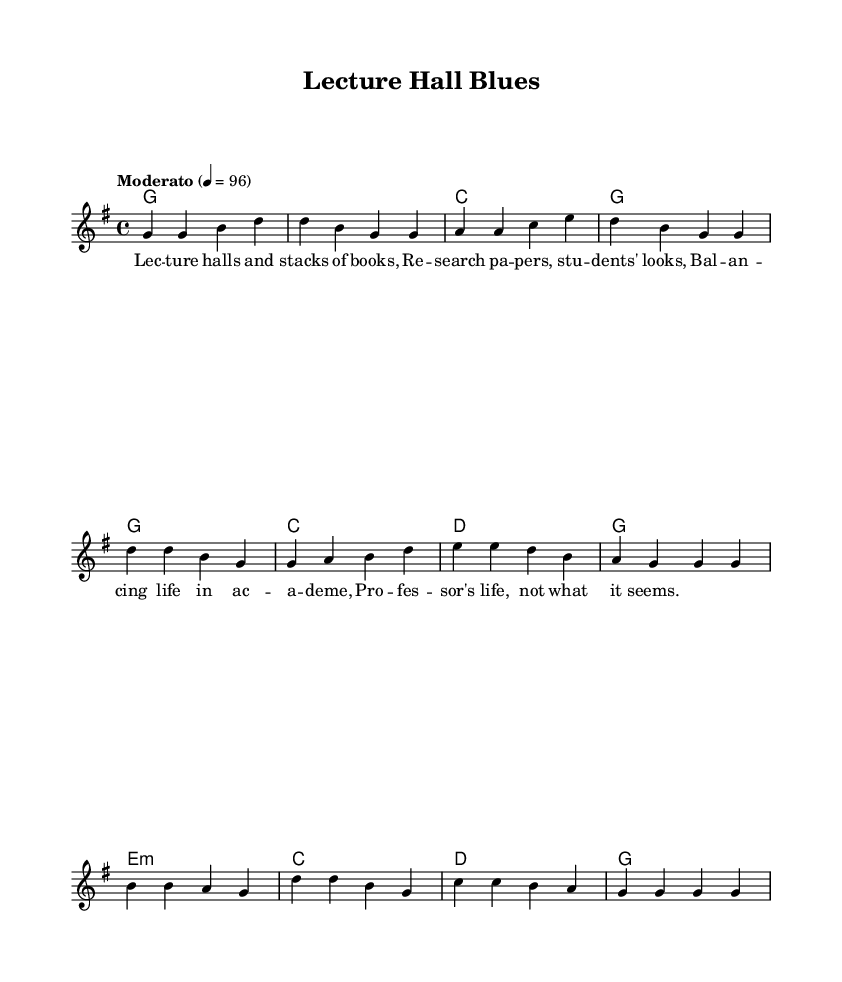What is the key signature of this music? The key signature is indicated by the presence of one sharp, which correlates with G major.
Answer: G major What is the time signature of the piece? The time signature is shown at the beginning of the score as 4/4, indicating that there are four beats per measure.
Answer: 4/4 What is the tempo marking of this piece? The tempo marking at the beginning states "Moderato" and provides a specific metronome marking of 96 beats per minute.
Answer: Moderato What are the first four notes of the melody? The melody begins with a sequence of notes: G, G, B, D, which can be identified from the first few notes under the "lead" voice.
Answer: G, G, B, D How many sections does the song contain? The sheet music is divided into three distinct sections: the Verse, the Chorus, and the Bridge. This is outlined in the structure of the lyrics and melodies.
Answer: Three What is the emotional theme of the lyrics as suggested by the music? The lyrics suggest a theme of balancing academic life and the challenges faced by a professor, reflected in the overall tone of the song.
Answer: Balancing academic life What chords are used in the bridge section? The bridge consists of the following chords: E minor, C major, D major, and G major, as indicated in the chord progression.
Answer: E minor, C, D, G 